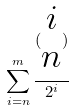<formula> <loc_0><loc_0><loc_500><loc_500>\sum _ { i = n } ^ { m } \frac { ( \begin{matrix} i \\ n \end{matrix} ) } { 2 ^ { i } }</formula> 